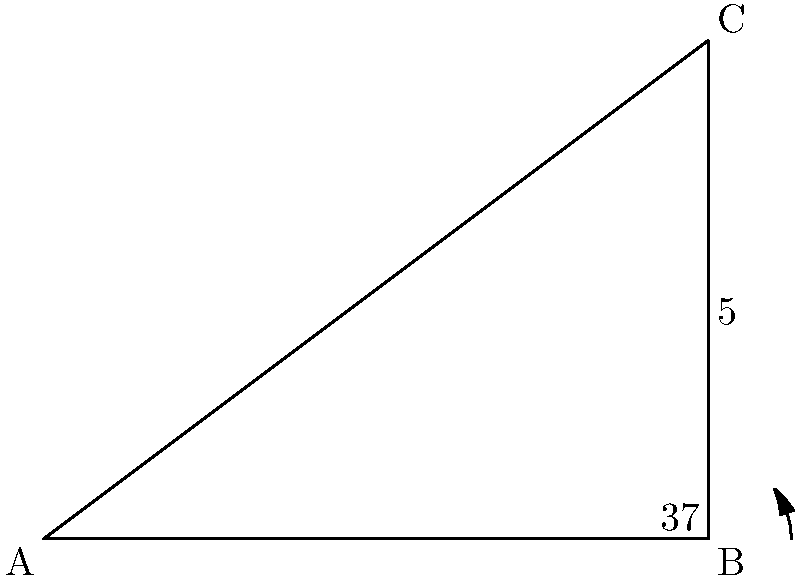In this right triangle, the hypotenuse is 5 units long, and one of the angles is 37°. Calculate the length of the side adjacent to the 37° angle, rounding your answer to two decimal places. How might this calculation be relevant to optimizing server rack placement in a Google data center? Let's solve this step-by-step:

1) In a right triangle, we can use the cosine function to find the adjacent side when we know the hypotenuse and an angle.

2) The formula is: $\cos(\theta) = \frac{\text{adjacent}}{\text{hypotenuse}}$

3) We know:
   - $\theta = 37°$
   - $\text{hypotenuse} = 5$

4) Let's call the adjacent side $x$. We can write:

   $\cos(37°) = \frac{x}{5}$

5) To solve for $x$, multiply both sides by 5:

   $x = 5 \cos(37°)$

6) Using a calculator:

   $x = 5 \times 0.7986355100472928 = 3.9931775502364637$

7) Rounding to two decimal places:

   $x \approx 3.99$

This calculation could be relevant for optimizing server rack placement in a Google data center by ensuring efficient use of space. Understanding the dimensions of triangular spaces could help in arranging server racks at angles to maximize cooling efficiency or cable management.
Answer: $3.99$ units 